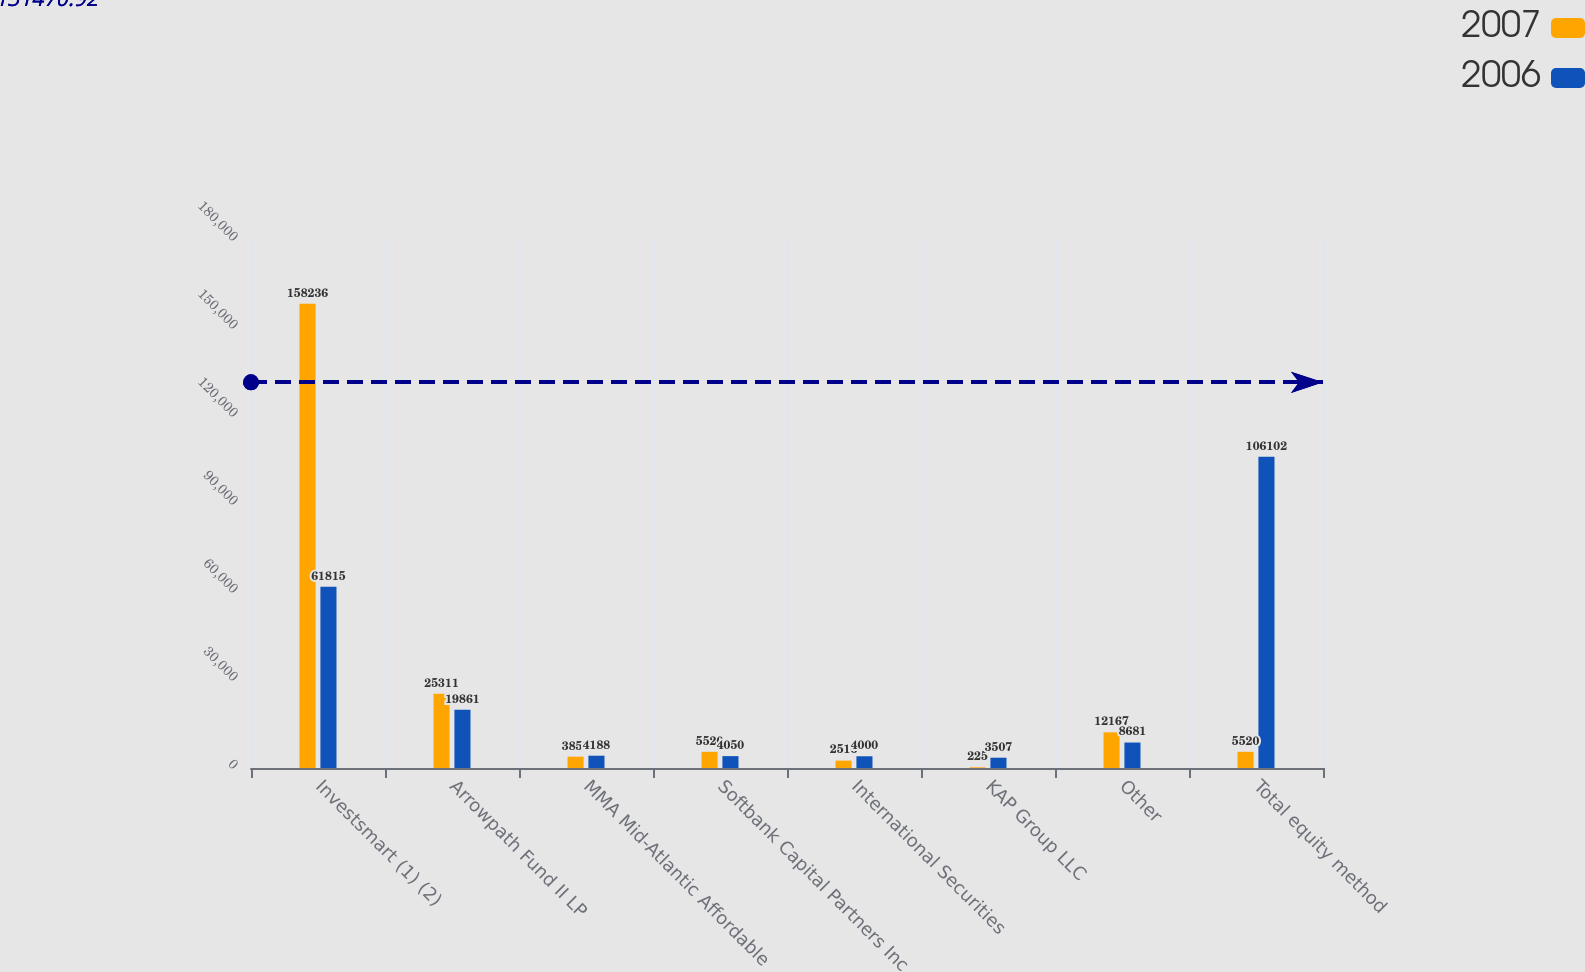<chart> <loc_0><loc_0><loc_500><loc_500><stacked_bar_chart><ecel><fcel>Investsmart (1) (2)<fcel>Arrowpath Fund II LP<fcel>MMA Mid-Atlantic Affordable<fcel>Softbank Capital Partners Inc<fcel>International Securities<fcel>KAP Group LLC<fcel>Other<fcel>Total equity method<nl><fcel>2007<fcel>158236<fcel>25311<fcel>3859<fcel>5520<fcel>2516<fcel>225<fcel>12167<fcel>5520<nl><fcel>2006<fcel>61815<fcel>19861<fcel>4188<fcel>4050<fcel>4000<fcel>3507<fcel>8681<fcel>106102<nl></chart> 